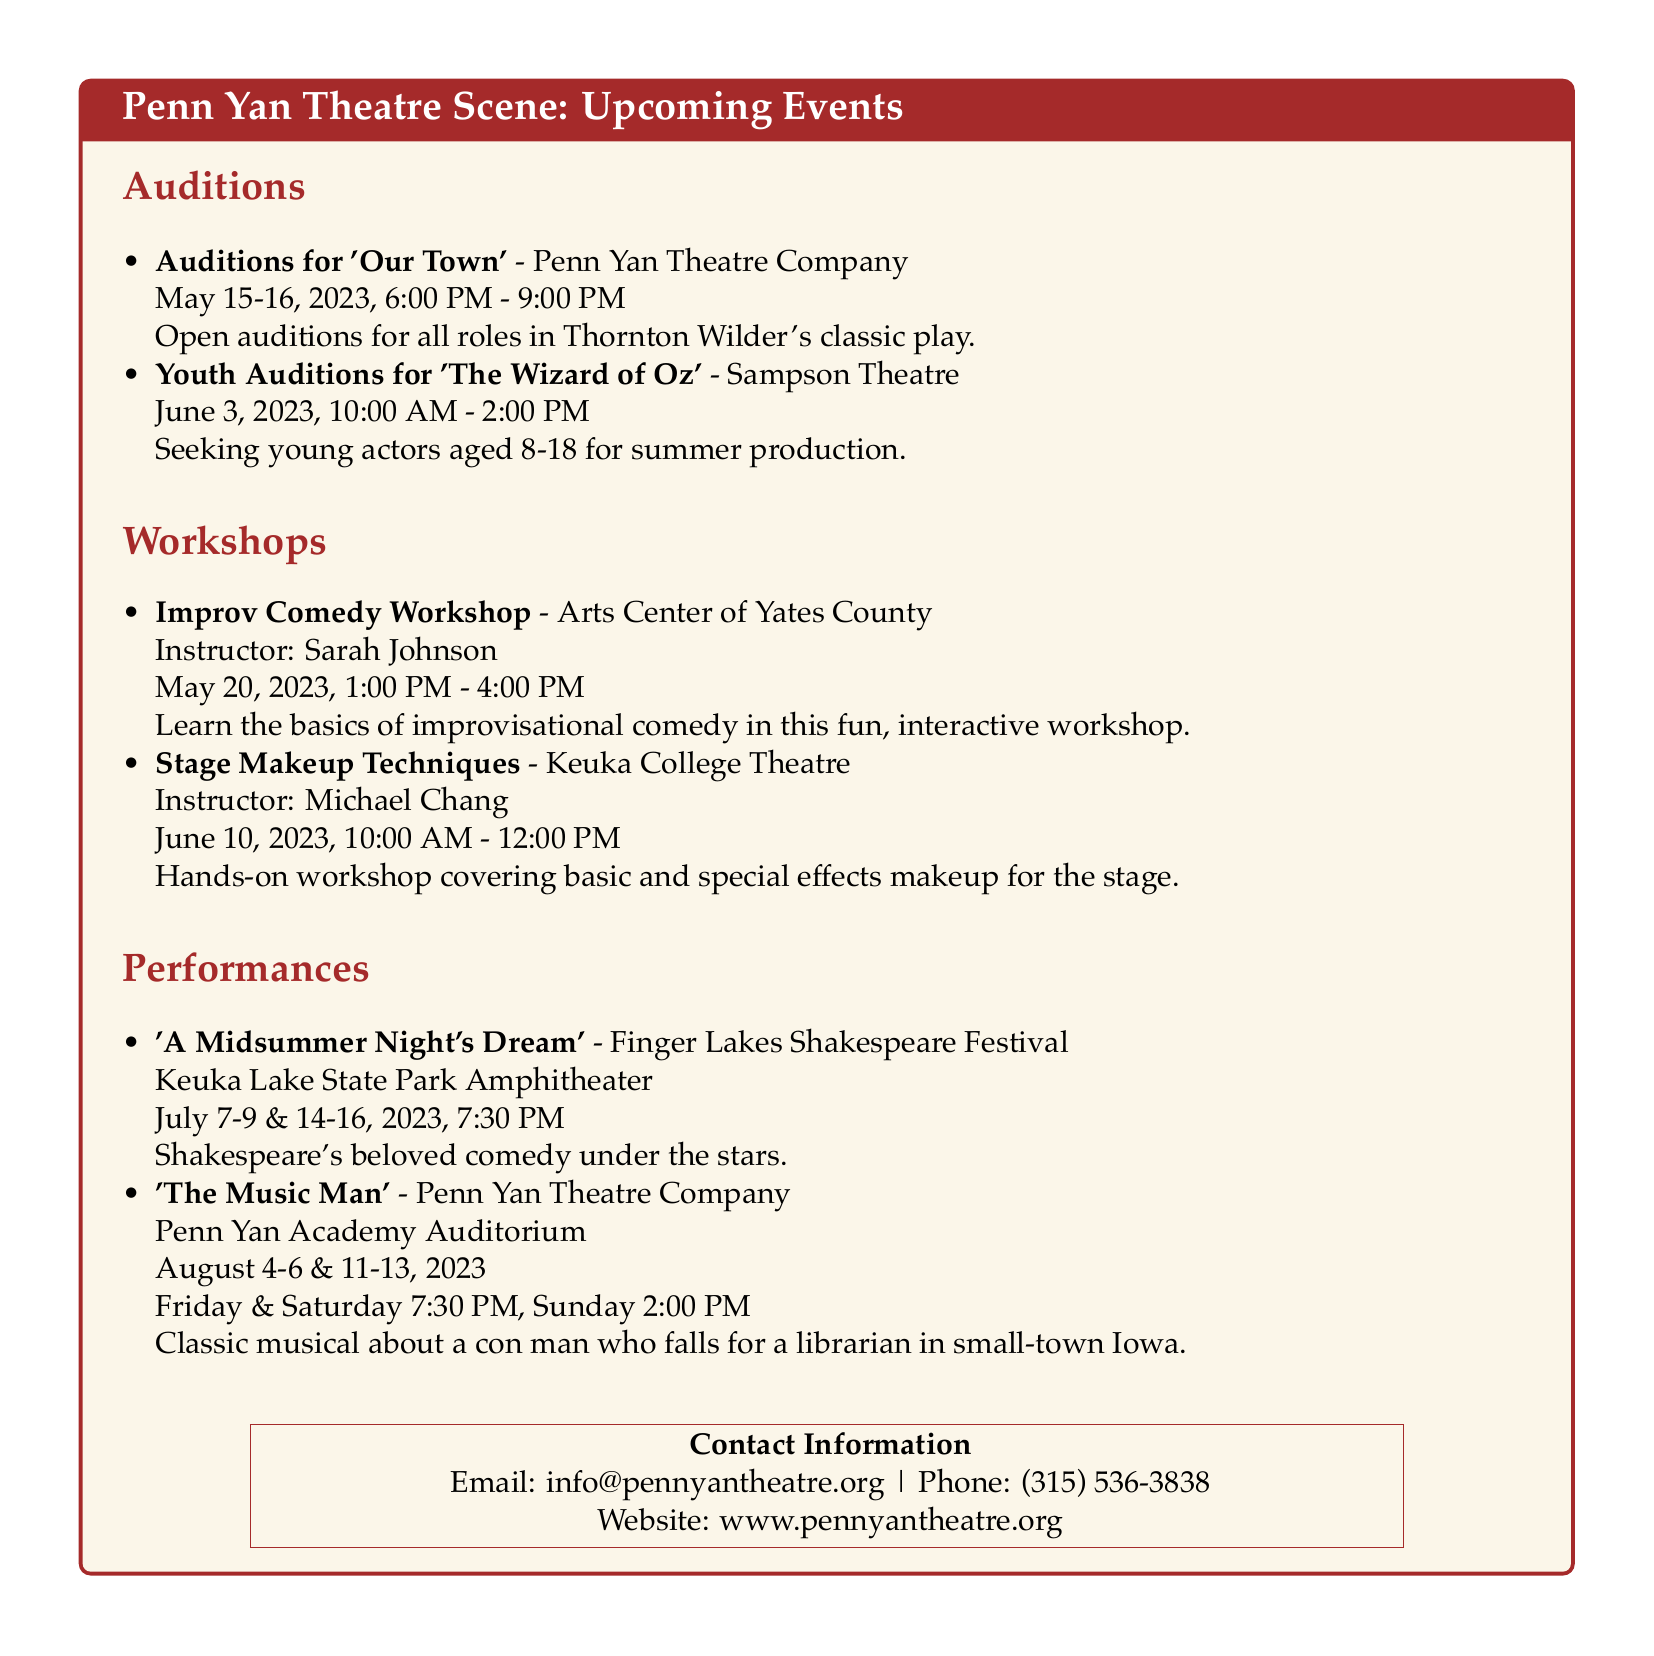What are the dates for auditions for 'Our Town'? The auditions for 'Our Town' are scheduled for May 15-16, 2023.
Answer: May 15-16, 2023 Who is the instructor for the Improv Comedy Workshop? The document specifies that Sarah Johnson is the instructor for the Improv Comedy Workshop.
Answer: Sarah Johnson What is the age range for the Youth Auditions for 'The Wizard of Oz'? The Youth Auditions are seeking young actors aged 8-18.
Answer: 8-18 When does 'A Midsummer Night's Dream' take place? The performances of 'A Midsummer Night's Dream' are scheduled for July 7-9 & 14-16, 2023.
Answer: July 7-9 & 14-16, 2023 Which theater is hosting the 'Stage Makeup Techniques' workshop? The 'Stage Makeup Techniques' workshop is being held at Keuka College Theatre.
Answer: Keuka College Theatre Which performance is described as "a classic musical about a con man"? The performance 'The Music Man' is described as a classic musical about a con man.
Answer: The Music Man What is the contact email for Penn Yan Theatre Company? The contact email provided in the document is info@pennyantheatre.org.
Answer: info@pennyantheatre.org How long is the Improv Comedy Workshop? The Improv Comedy Workshop is from 1:00 PM to 4:00 PM, lasting for 3 hours.
Answer: 3 hours 